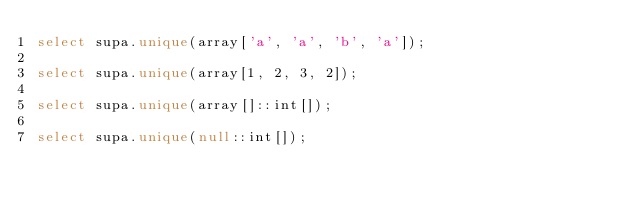Convert code to text. <code><loc_0><loc_0><loc_500><loc_500><_SQL_>select supa.unique(array['a', 'a', 'b', 'a']);

select supa.unique(array[1, 2, 3, 2]);

select supa.unique(array[]::int[]);

select supa.unique(null::int[]);
</code> 